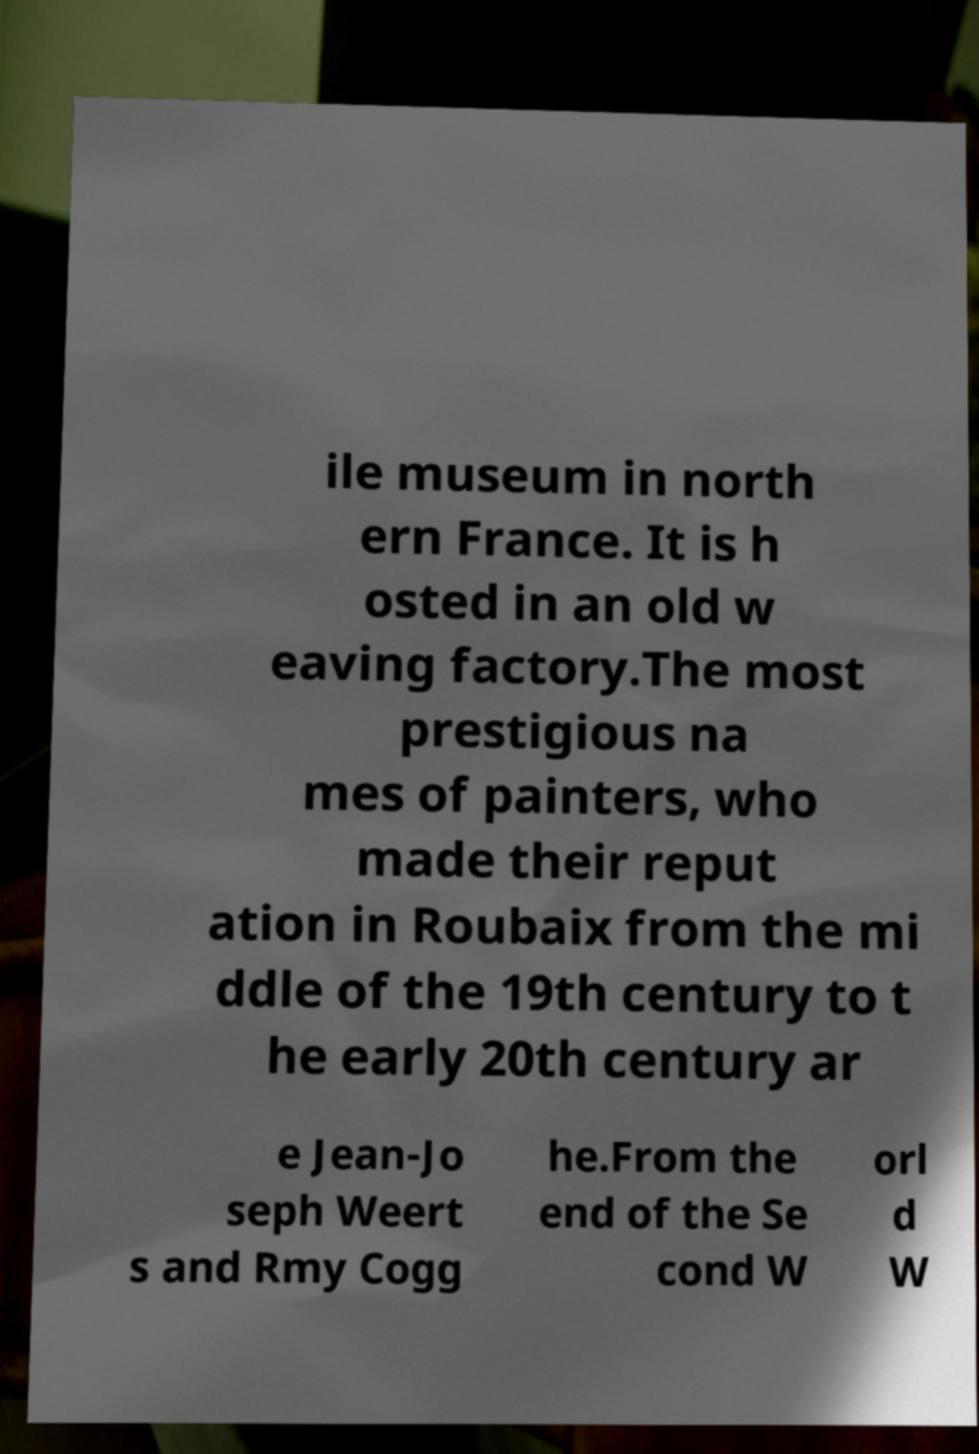Please identify and transcribe the text found in this image. ile museum in north ern France. It is h osted in an old w eaving factory.The most prestigious na mes of painters, who made their reput ation in Roubaix from the mi ddle of the 19th century to t he early 20th century ar e Jean-Jo seph Weert s and Rmy Cogg he.From the end of the Se cond W orl d W 